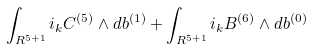Convert formula to latex. <formula><loc_0><loc_0><loc_500><loc_500>\int _ { R ^ { 5 + 1 } } i _ { k } C ^ { ( 5 ) } \wedge d b ^ { ( 1 ) } + \int _ { R ^ { 5 + 1 } } i _ { k } B ^ { ( 6 ) } \wedge d b ^ { ( 0 ) }</formula> 